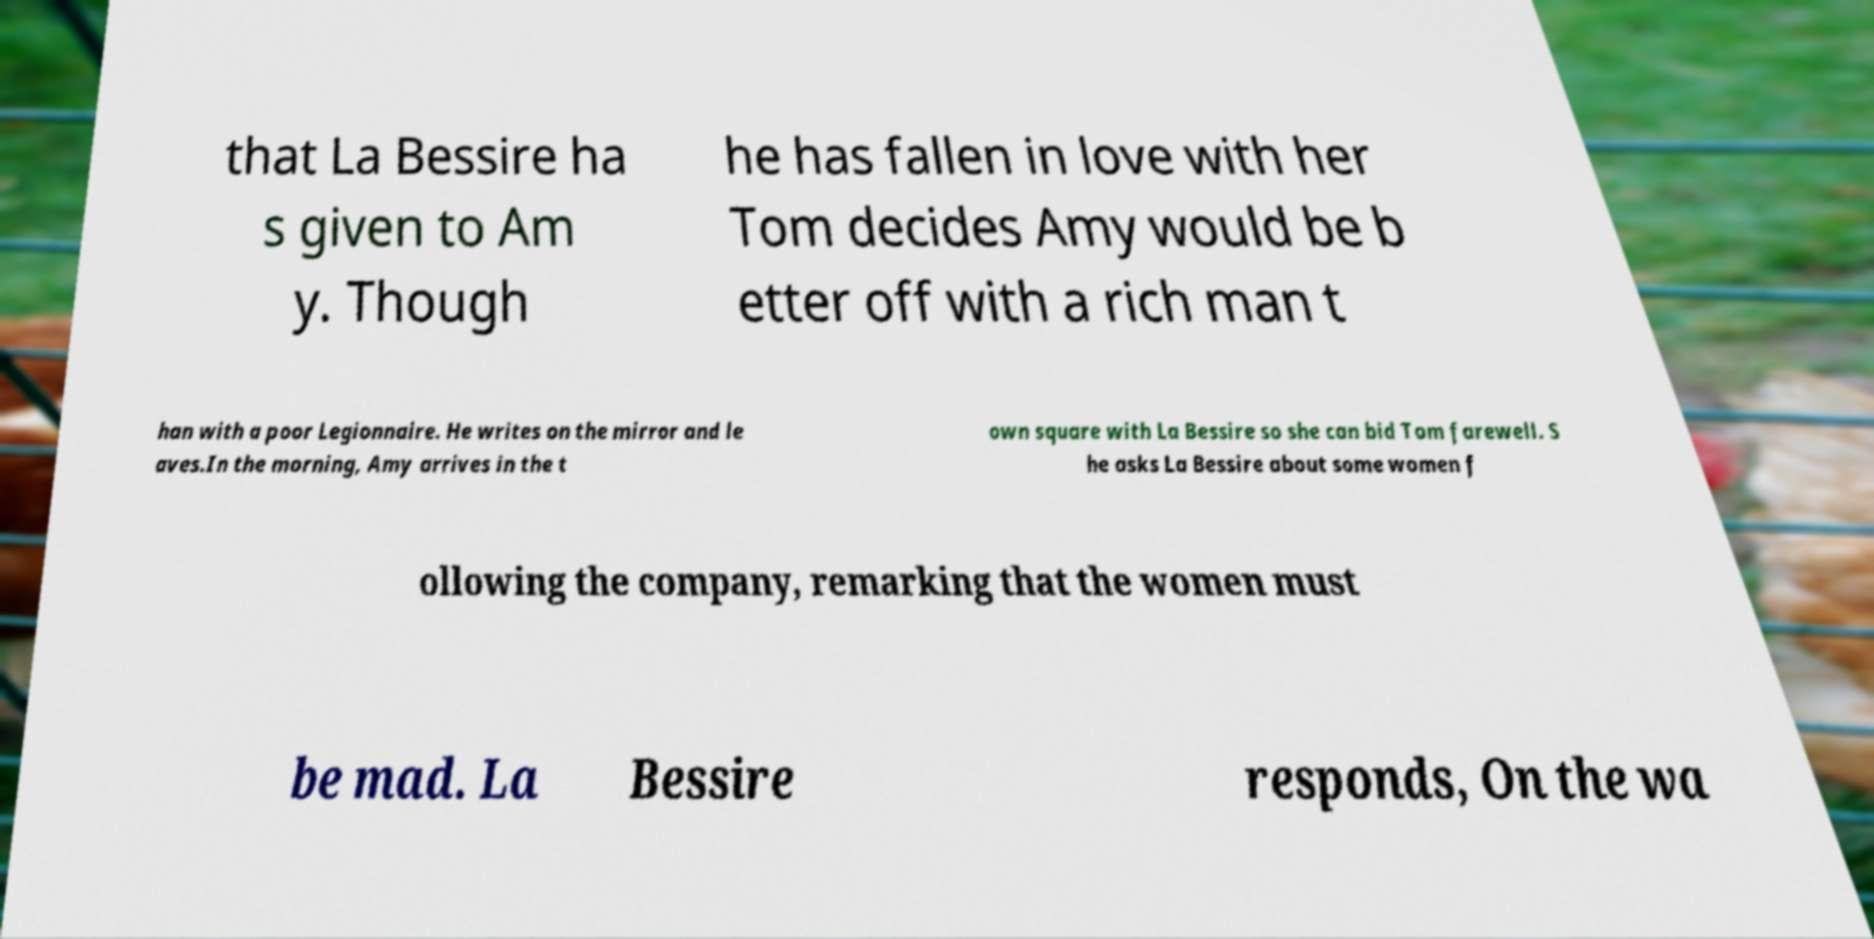There's text embedded in this image that I need extracted. Can you transcribe it verbatim? that La Bessire ha s given to Am y. Though he has fallen in love with her Tom decides Amy would be b etter off with a rich man t han with a poor Legionnaire. He writes on the mirror and le aves.In the morning, Amy arrives in the t own square with La Bessire so she can bid Tom farewell. S he asks La Bessire about some women f ollowing the company, remarking that the women must be mad. La Bessire responds, On the wa 